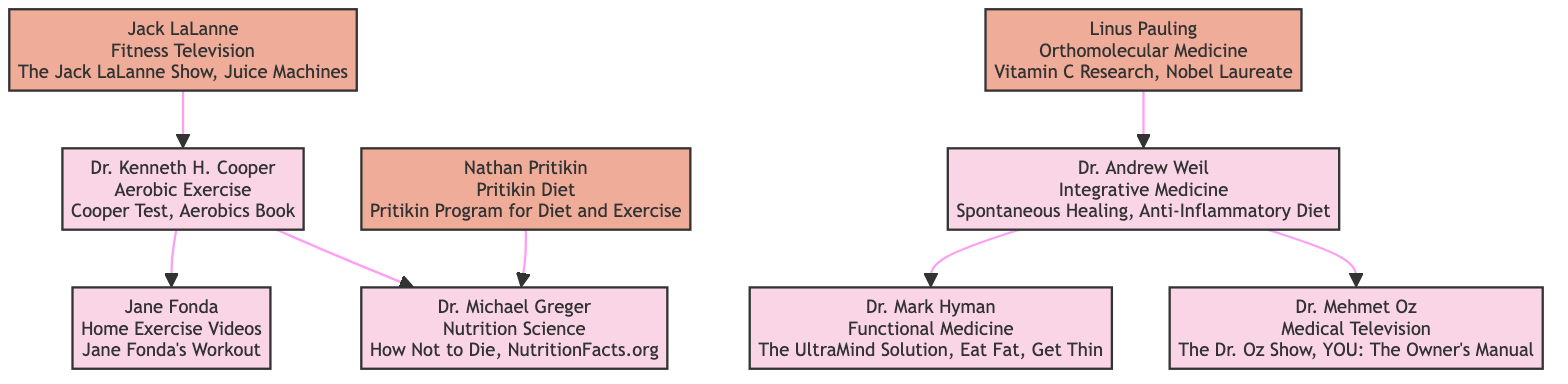What is Dr. Kenneth H. Cooper known for? The diagram states that Dr. Kenneth H. Cooper is known for "Cooper Test, Aerobics Book." This information is explicitly mentioned in his node description within the family tree.
Answer: Cooper Test, Aerobics Book Who influenced Dr. Andrew Weil? According to the diagram, Dr. Andrew Weil was influenced by Linus Pauling. The influence is indicated by a direct connection in the family tree from Pauling to Weil.
Answer: Linus Pauling How many experts are there in the diagram? The diagram contains seven expert nodes: Dr. Kenneth H. Cooper, Jane Fonda, Dr. Michael Greger, Dr. Andrew Weil, Dr. Mark Hyman, Dr. Mehmet Oz, and Nathan Pritikin. Counting these nodes provides the total number of experts.
Answer: 7 Which expert is known for the Anti-Inflammatory Diet? The expert associated with the Anti-Inflammatory Diet is Dr. Andrew Weil, as described in his node where this method is stated.
Answer: Dr. Andrew Weil Who is the first influencer in the family tree? The first influencer presented in the diagram is Jack LaLanne, indicated by his position in the family tree, where he influences Dr. Kenneth H. Cooper.
Answer: Jack LaLanne What type of exercise did Dr. Kenneth H. Cooper promote? The diagram indicates that Dr. Kenneth H. Cooper promoted "Aerobic Exercise," found within his node, providing a straightforward answer regarding his contributions.
Answer: Aerobic Exercise Which two experts were influenced by Dr. Andrew Weil? According to the diagram, the two experts influenced by Dr. Andrew Weil are Dr. Mark Hyman and Dr. Mehmet Oz, as indicated by the direct connections from Weil to these experts.
Answer: Dr. Mark Hyman, Dr. Mehmet Oz How did Nathan Pritikin influence Dr. Michael Greger? Nathan Pritikin influenced Dr. Michael Greger by introducing the Pritikin Diet. This is shown in the diagram as a direct connection from Pritikin to Greger, indicating the influence and the specific method.
Answer: Pritikin Diet What is the relationship between Dr. Kenneth H. Cooper and Jane Fonda? Dr. Kenneth H. Cooper is an influencer of Jane Fonda, as depicted in the diagram with a direct link from Cooper to Fonda. This indicates that Cooper's work influenced Fonda's contributions to fitness.
Answer: Influencer 